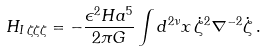<formula> <loc_0><loc_0><loc_500><loc_500>H _ { I \, \zeta \zeta \zeta } = - \frac { \epsilon ^ { 2 } H a ^ { 5 } } { 2 \pi G } \int d ^ { 2 \nu } x \, \dot { \zeta } ^ { 2 } \nabla ^ { - 2 } \dot { \zeta } \, .</formula> 